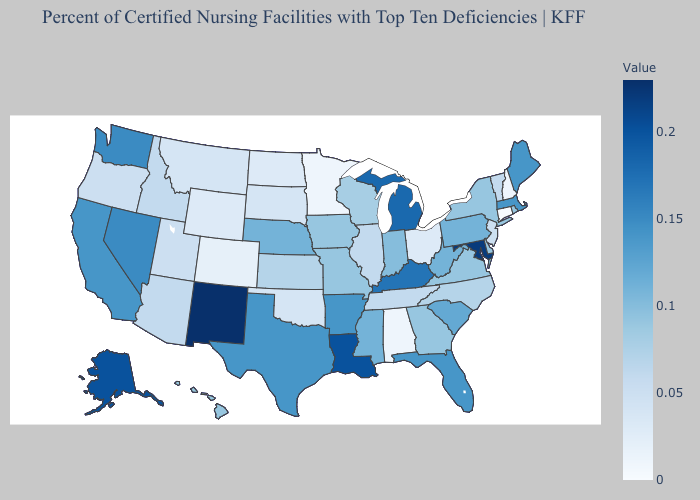Does Maryland have the lowest value in the South?
Write a very short answer. No. Does Wisconsin have a higher value than Alaska?
Concise answer only. No. Does the map have missing data?
Concise answer only. No. Does Georgia have the highest value in the South?
Short answer required. No. Does the map have missing data?
Keep it brief. No. Does Oklahoma have a higher value than Massachusetts?
Quick response, please. No. Does Vermont have the lowest value in the Northeast?
Give a very brief answer. No. Among the states that border West Virginia , does Maryland have the highest value?
Give a very brief answer. Yes. Which states have the highest value in the USA?
Answer briefly. New Mexico. Does Colorado have the lowest value in the West?
Keep it brief. Yes. 